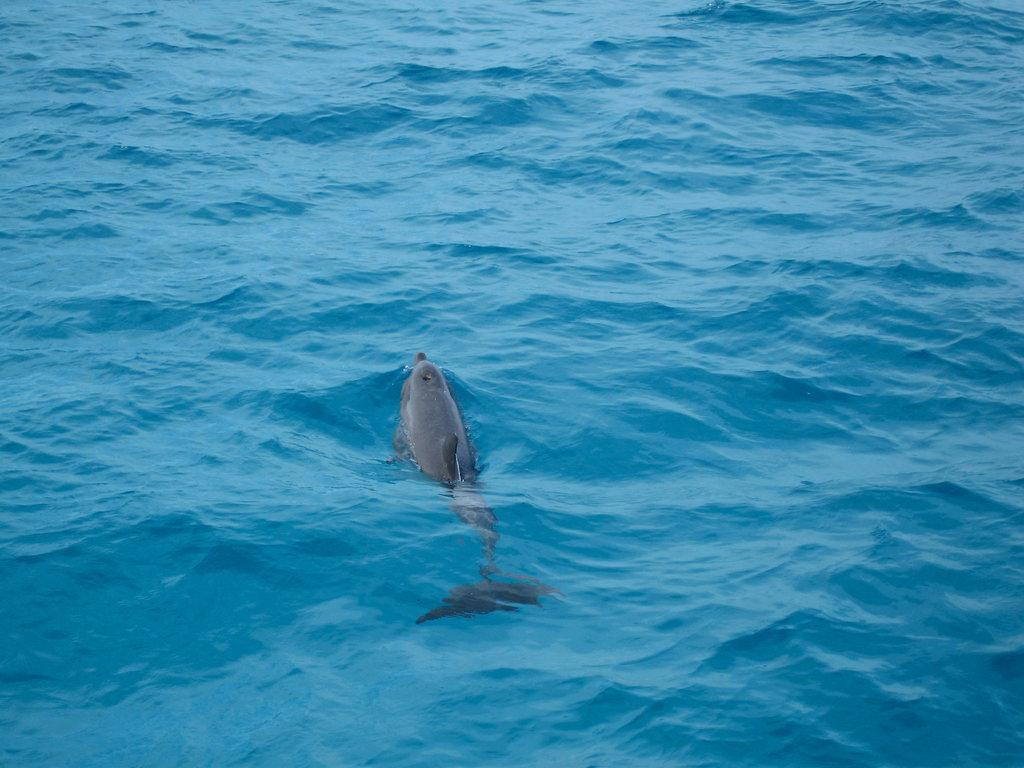What animal is featured in the image? There is a dolphin in the image. What is the dolphin doing in the image? The dolphin is swimming in the water. Where is the cake located in the image? There is no cake present in the image. What type of lock is used to secure the cannon in the image? There is no cannon or lock present in the image. 